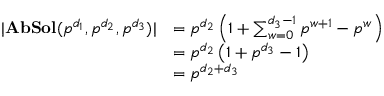Convert formula to latex. <formula><loc_0><loc_0><loc_500><loc_500>\begin{array} { r l } { | A b S o l ( p ^ { d _ { 1 } } , p ^ { d _ { 2 } } , p ^ { d _ { 3 } } ) | } & { = p ^ { d _ { 2 } } \left ( 1 + \sum _ { w = 0 } ^ { d _ { 3 } - 1 } p ^ { w + 1 } - p ^ { w } \right ) } \\ & { = p ^ { d _ { 2 } } \left ( 1 + p ^ { d _ { 3 } } - 1 \right ) } \\ & { = p ^ { d _ { 2 } + d _ { 3 } } } \end{array}</formula> 